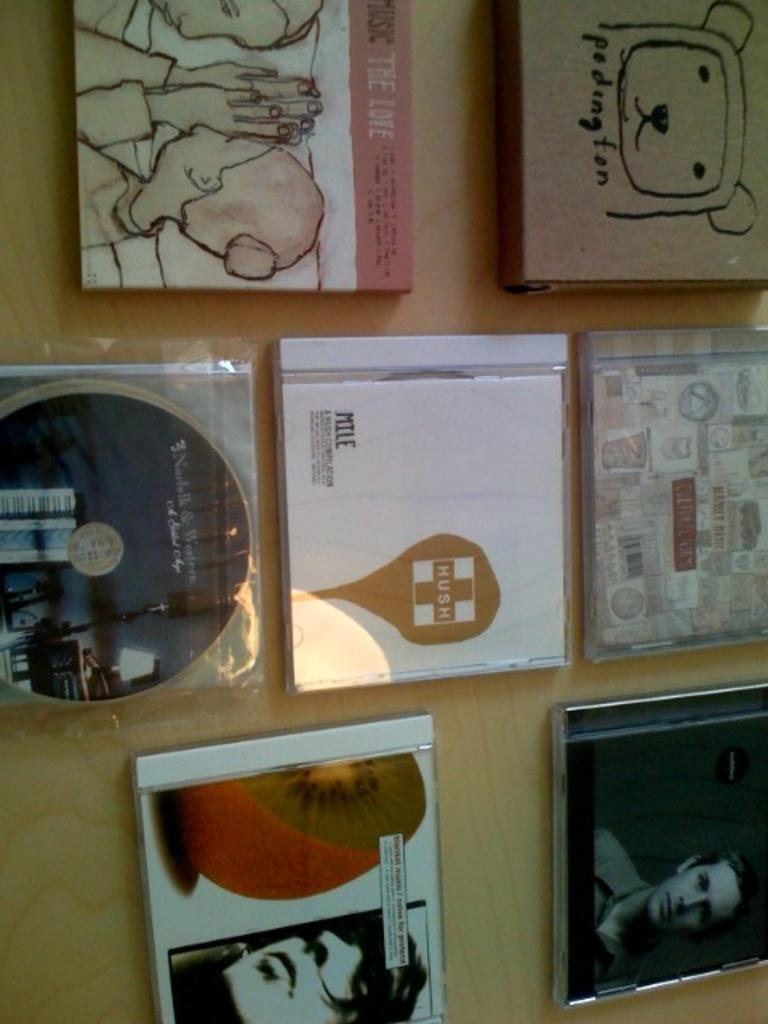What type of objects can be seen in the image? There are CDs and boxes in the image. What material is the surface on which the objects are placed? The wooden surface is present in the image. What type of group is performing with a ball in the image? There is no group or ball present in the image; it only features CDs and boxes on a wooden surface. Can you tell me how many goats are visible in the image? There are no goats present in the image. 